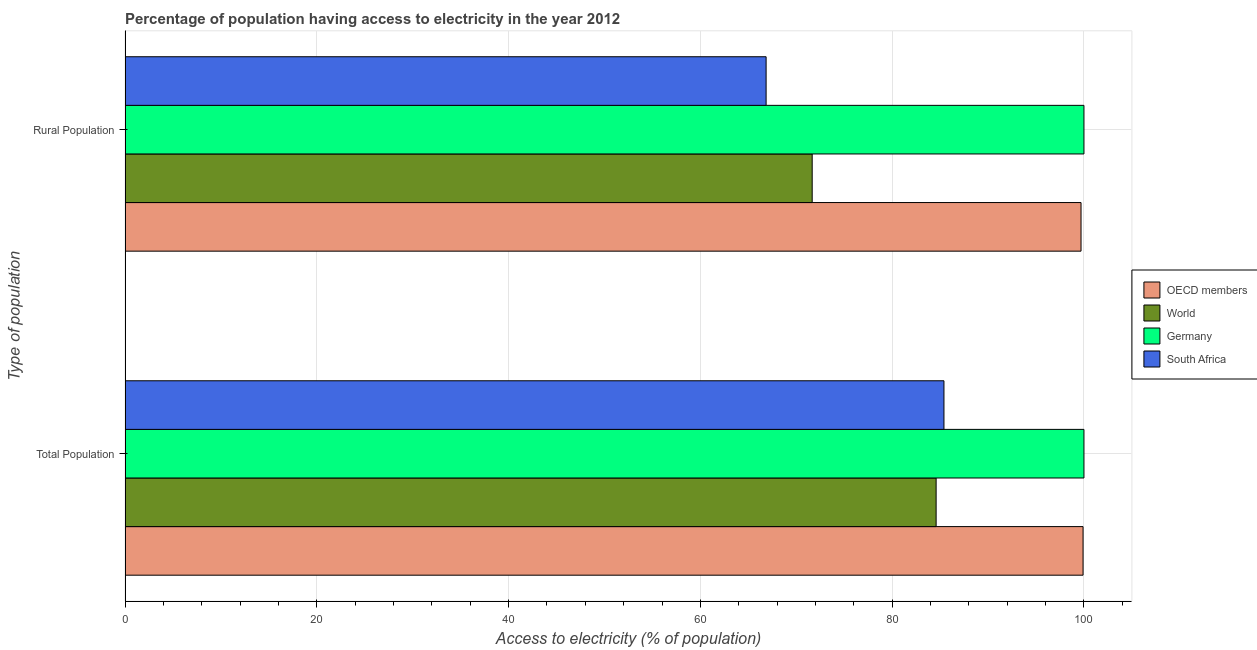How many different coloured bars are there?
Your response must be concise. 4. How many groups of bars are there?
Provide a succinct answer. 2. How many bars are there on the 1st tick from the bottom?
Make the answer very short. 4. What is the label of the 2nd group of bars from the top?
Keep it short and to the point. Total Population. What is the percentage of population having access to electricity in South Africa?
Ensure brevity in your answer.  85.4. Across all countries, what is the maximum percentage of population having access to electricity?
Give a very brief answer. 100. Across all countries, what is the minimum percentage of rural population having access to electricity?
Your answer should be compact. 66.85. In which country was the percentage of rural population having access to electricity maximum?
Keep it short and to the point. Germany. In which country was the percentage of rural population having access to electricity minimum?
Keep it short and to the point. South Africa. What is the total percentage of rural population having access to electricity in the graph?
Your answer should be compact. 338.21. What is the difference between the percentage of population having access to electricity in World and that in Germany?
Make the answer very short. -15.42. What is the difference between the percentage of population having access to electricity in OECD members and the percentage of rural population having access to electricity in Germany?
Offer a terse response. -0.09. What is the average percentage of population having access to electricity per country?
Provide a short and direct response. 92.47. What is the difference between the percentage of rural population having access to electricity and percentage of population having access to electricity in South Africa?
Your answer should be compact. -18.55. What is the ratio of the percentage of rural population having access to electricity in World to that in OECD members?
Your answer should be very brief. 0.72. In how many countries, is the percentage of population having access to electricity greater than the average percentage of population having access to electricity taken over all countries?
Your answer should be compact. 2. What does the 2nd bar from the bottom in Total Population represents?
Your answer should be compact. World. How many bars are there?
Offer a very short reply. 8. Are all the bars in the graph horizontal?
Ensure brevity in your answer.  Yes. Where does the legend appear in the graph?
Provide a succinct answer. Center right. How many legend labels are there?
Keep it short and to the point. 4. What is the title of the graph?
Your answer should be very brief. Percentage of population having access to electricity in the year 2012. Does "Cote d'Ivoire" appear as one of the legend labels in the graph?
Make the answer very short. No. What is the label or title of the X-axis?
Give a very brief answer. Access to electricity (% of population). What is the label or title of the Y-axis?
Make the answer very short. Type of population. What is the Access to electricity (% of population) in OECD members in Total Population?
Provide a short and direct response. 99.91. What is the Access to electricity (% of population) of World in Total Population?
Offer a terse response. 84.58. What is the Access to electricity (% of population) in South Africa in Total Population?
Keep it short and to the point. 85.4. What is the Access to electricity (% of population) in OECD members in Rural Population?
Ensure brevity in your answer.  99.7. What is the Access to electricity (% of population) in World in Rural Population?
Offer a very short reply. 71.66. What is the Access to electricity (% of population) of South Africa in Rural Population?
Offer a terse response. 66.85. Across all Type of population, what is the maximum Access to electricity (% of population) of OECD members?
Ensure brevity in your answer.  99.91. Across all Type of population, what is the maximum Access to electricity (% of population) in World?
Ensure brevity in your answer.  84.58. Across all Type of population, what is the maximum Access to electricity (% of population) in Germany?
Provide a short and direct response. 100. Across all Type of population, what is the maximum Access to electricity (% of population) of South Africa?
Your response must be concise. 85.4. Across all Type of population, what is the minimum Access to electricity (% of population) in OECD members?
Your answer should be very brief. 99.7. Across all Type of population, what is the minimum Access to electricity (% of population) of World?
Your answer should be compact. 71.66. Across all Type of population, what is the minimum Access to electricity (% of population) of Germany?
Your answer should be very brief. 100. Across all Type of population, what is the minimum Access to electricity (% of population) of South Africa?
Ensure brevity in your answer.  66.85. What is the total Access to electricity (% of population) in OECD members in the graph?
Ensure brevity in your answer.  199.6. What is the total Access to electricity (% of population) in World in the graph?
Provide a succinct answer. 156.24. What is the total Access to electricity (% of population) of Germany in the graph?
Give a very brief answer. 200. What is the total Access to electricity (% of population) of South Africa in the graph?
Your answer should be compact. 152.25. What is the difference between the Access to electricity (% of population) of OECD members in Total Population and that in Rural Population?
Offer a terse response. 0.21. What is the difference between the Access to electricity (% of population) of World in Total Population and that in Rural Population?
Offer a terse response. 12.92. What is the difference between the Access to electricity (% of population) of Germany in Total Population and that in Rural Population?
Your answer should be very brief. 0. What is the difference between the Access to electricity (% of population) of South Africa in Total Population and that in Rural Population?
Provide a succinct answer. 18.55. What is the difference between the Access to electricity (% of population) of OECD members in Total Population and the Access to electricity (% of population) of World in Rural Population?
Make the answer very short. 28.25. What is the difference between the Access to electricity (% of population) of OECD members in Total Population and the Access to electricity (% of population) of Germany in Rural Population?
Offer a very short reply. -0.09. What is the difference between the Access to electricity (% of population) of OECD members in Total Population and the Access to electricity (% of population) of South Africa in Rural Population?
Your response must be concise. 33.05. What is the difference between the Access to electricity (% of population) in World in Total Population and the Access to electricity (% of population) in Germany in Rural Population?
Offer a terse response. -15.42. What is the difference between the Access to electricity (% of population) in World in Total Population and the Access to electricity (% of population) in South Africa in Rural Population?
Keep it short and to the point. 17.73. What is the difference between the Access to electricity (% of population) in Germany in Total Population and the Access to electricity (% of population) in South Africa in Rural Population?
Offer a terse response. 33.15. What is the average Access to electricity (% of population) of OECD members per Type of population?
Your answer should be very brief. 99.8. What is the average Access to electricity (% of population) of World per Type of population?
Ensure brevity in your answer.  78.12. What is the average Access to electricity (% of population) in Germany per Type of population?
Offer a very short reply. 100. What is the average Access to electricity (% of population) of South Africa per Type of population?
Provide a succinct answer. 76.13. What is the difference between the Access to electricity (% of population) in OECD members and Access to electricity (% of population) in World in Total Population?
Offer a very short reply. 15.32. What is the difference between the Access to electricity (% of population) in OECD members and Access to electricity (% of population) in Germany in Total Population?
Provide a short and direct response. -0.09. What is the difference between the Access to electricity (% of population) in OECD members and Access to electricity (% of population) in South Africa in Total Population?
Your response must be concise. 14.51. What is the difference between the Access to electricity (% of population) in World and Access to electricity (% of population) in Germany in Total Population?
Your answer should be very brief. -15.42. What is the difference between the Access to electricity (% of population) of World and Access to electricity (% of population) of South Africa in Total Population?
Keep it short and to the point. -0.82. What is the difference between the Access to electricity (% of population) in Germany and Access to electricity (% of population) in South Africa in Total Population?
Make the answer very short. 14.6. What is the difference between the Access to electricity (% of population) in OECD members and Access to electricity (% of population) in World in Rural Population?
Ensure brevity in your answer.  28.04. What is the difference between the Access to electricity (% of population) of OECD members and Access to electricity (% of population) of Germany in Rural Population?
Your answer should be compact. -0.3. What is the difference between the Access to electricity (% of population) in OECD members and Access to electricity (% of population) in South Africa in Rural Population?
Provide a short and direct response. 32.84. What is the difference between the Access to electricity (% of population) of World and Access to electricity (% of population) of Germany in Rural Population?
Keep it short and to the point. -28.34. What is the difference between the Access to electricity (% of population) in World and Access to electricity (% of population) in South Africa in Rural Population?
Provide a short and direct response. 4.81. What is the difference between the Access to electricity (% of population) in Germany and Access to electricity (% of population) in South Africa in Rural Population?
Your answer should be very brief. 33.15. What is the ratio of the Access to electricity (% of population) in World in Total Population to that in Rural Population?
Give a very brief answer. 1.18. What is the ratio of the Access to electricity (% of population) of South Africa in Total Population to that in Rural Population?
Provide a short and direct response. 1.28. What is the difference between the highest and the second highest Access to electricity (% of population) of OECD members?
Your answer should be compact. 0.21. What is the difference between the highest and the second highest Access to electricity (% of population) of World?
Provide a succinct answer. 12.92. What is the difference between the highest and the second highest Access to electricity (% of population) of Germany?
Offer a terse response. 0. What is the difference between the highest and the second highest Access to electricity (% of population) of South Africa?
Provide a succinct answer. 18.55. What is the difference between the highest and the lowest Access to electricity (% of population) in OECD members?
Offer a terse response. 0.21. What is the difference between the highest and the lowest Access to electricity (% of population) of World?
Your response must be concise. 12.92. What is the difference between the highest and the lowest Access to electricity (% of population) in South Africa?
Your answer should be compact. 18.55. 